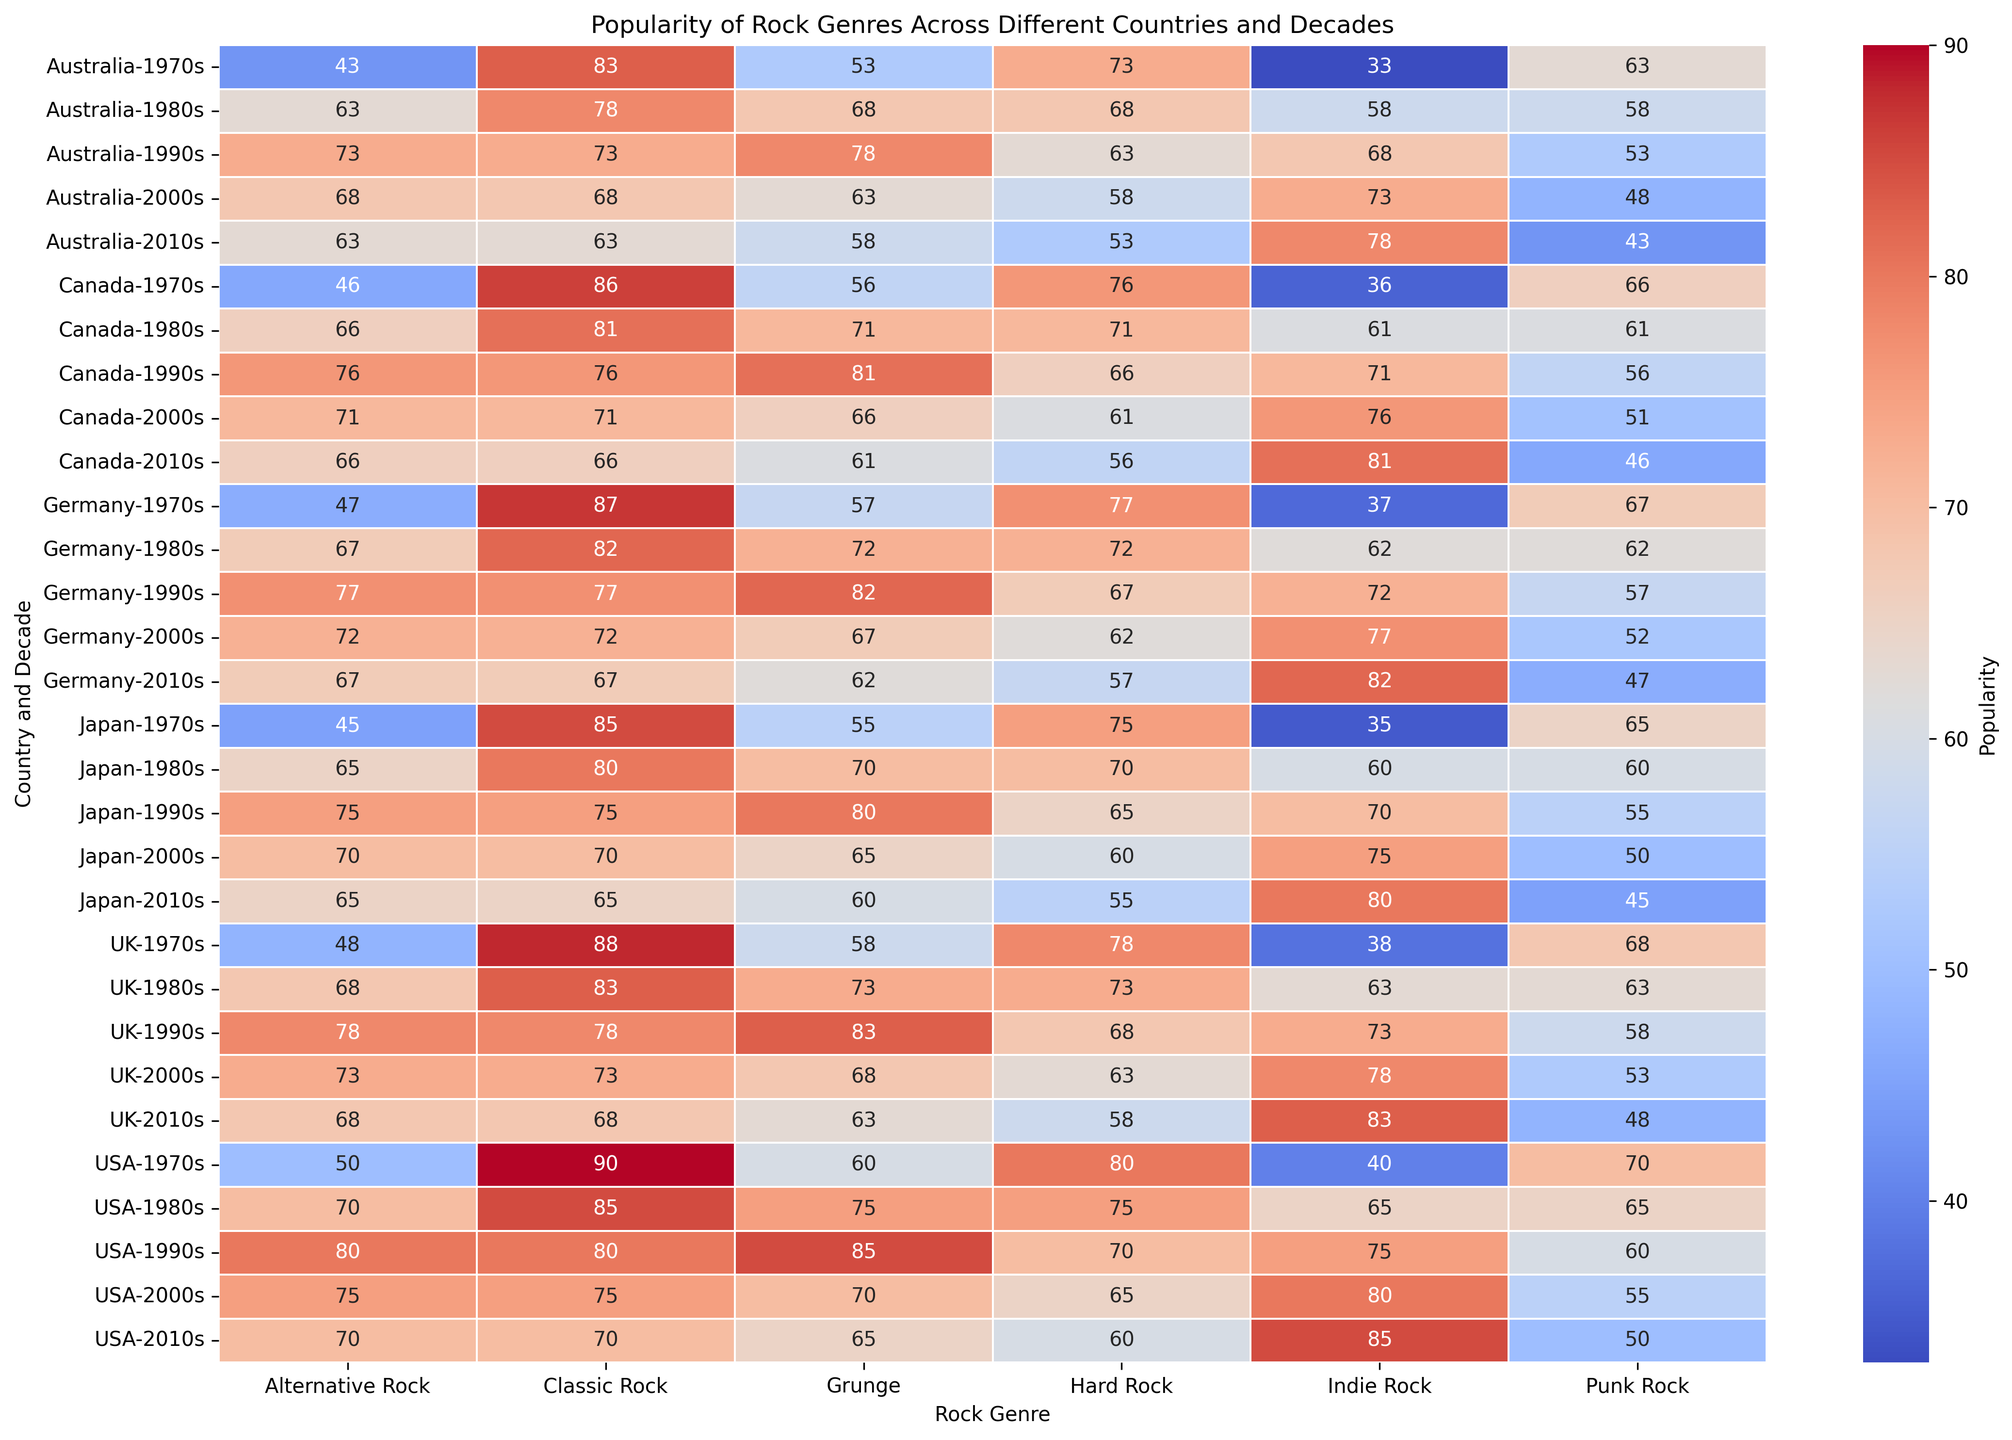Which country had the highest popularity of Grunge in the 1990s? Look at the 1990s row for each country and compare the Grunge popularity value. Find the highest value.
Answer: USA Which genre gained the most popularity in the USA from the 2000s to the 2010s? Compare the changes in popularity for each genre from the 2000s to the 2010s in the USA. Calculate the differences and find the maximum. Classic Rock: 75-70=-5, Hard Rock: 65-60=-5, Punk Rock: 55-50=-5, Grunge: 70-65=-5, Alternative Rock: 75-70=-5, Indie Rock: 80-85=5
Answer: Indie Rock What is the average popularity of Classic Rock in the 1970s across all countries? Sum the Classic Rock values in the 1970s for all countries and divide by the number of countries. (90+88+87+85+83+86)/6 = 518/6
Answer: 86.3 Which genre was consistently less popular in Japan from the 1970s to the 2010s? Compare the popularity values across the decades for each genre in Japan. Identify the genre with consistently lower values.
Answer: Indie Rock Compare the trend of Hard Rock popularity in Germany and Canada from the 1970s to the 2010s. Which country shows a greater decline? Calculate the change in Hard Rock popularity from the 1970s to the 2010s for each country. Germany: 77-57=20, Canada: 76-56=20. Both showed a decline of 20.
Answer: Both countries showed the same decline Which rock genre became more popular in every decade in Australia? Check the popularity values for each genre in Australia across all decades. Identify if any genre has increasing popularity in every decade. None of the genres became more popular in every decade.
Answer: None What is the sum of Alternative Rock popularity in the 1980s for USA, UK, and Japan? Add the Alternative Rock values in the 1980s for these three countries. 70+68+65=203
Answer: 203 Which decade saw the highest overall popularity of Punk Rock in the USA? Check the Punk Rock popularity values for each decade in the USA and find the highest one. 1970s: 70, 1980s: 65, 1990s: 60, 2000s: 55, 2010s: 50
Answer: 1970s Did the popularity of Indie Rock in Canada increase, decrease, or stay the same from the 2000s to the 2010s? Compare the Indie Rock values for Canada in the 2000s and 2010s. 76 to 81 marks an increase.
Answer: Increase 